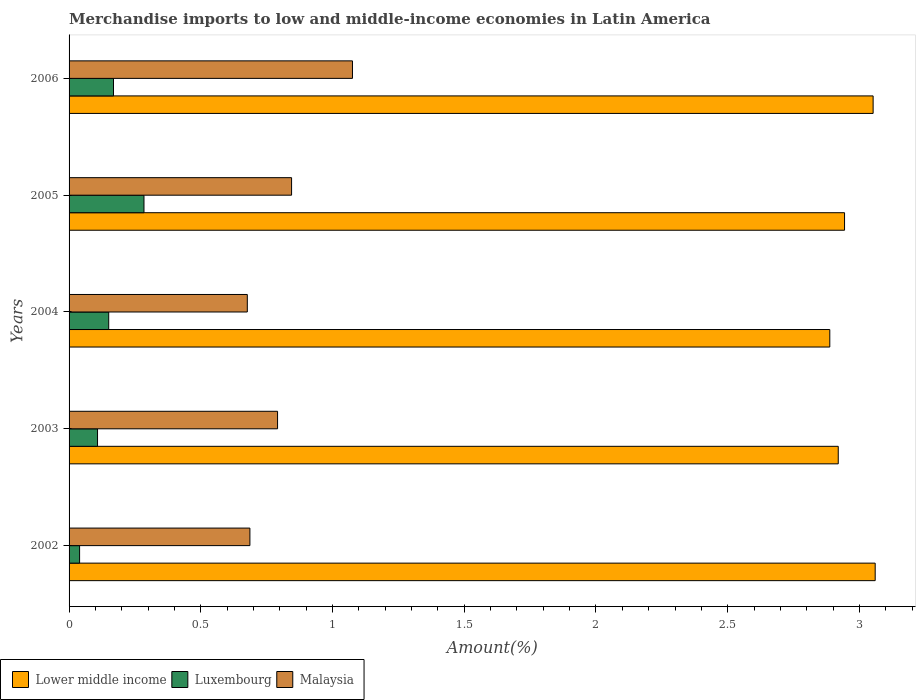Are the number of bars on each tick of the Y-axis equal?
Provide a short and direct response. Yes. What is the percentage of amount earned from merchandise imports in Lower middle income in 2006?
Provide a succinct answer. 3.05. Across all years, what is the maximum percentage of amount earned from merchandise imports in Lower middle income?
Provide a short and direct response. 3.06. Across all years, what is the minimum percentage of amount earned from merchandise imports in Luxembourg?
Your answer should be compact. 0.04. What is the total percentage of amount earned from merchandise imports in Lower middle income in the graph?
Make the answer very short. 14.86. What is the difference between the percentage of amount earned from merchandise imports in Lower middle income in 2002 and that in 2005?
Your response must be concise. 0.12. What is the difference between the percentage of amount earned from merchandise imports in Luxembourg in 2004 and the percentage of amount earned from merchandise imports in Lower middle income in 2006?
Your response must be concise. -2.9. What is the average percentage of amount earned from merchandise imports in Luxembourg per year?
Provide a short and direct response. 0.15. In the year 2006, what is the difference between the percentage of amount earned from merchandise imports in Lower middle income and percentage of amount earned from merchandise imports in Malaysia?
Provide a succinct answer. 1.98. In how many years, is the percentage of amount earned from merchandise imports in Malaysia greater than 0.7 %?
Ensure brevity in your answer.  3. What is the ratio of the percentage of amount earned from merchandise imports in Malaysia in 2004 to that in 2005?
Your answer should be very brief. 0.8. What is the difference between the highest and the second highest percentage of amount earned from merchandise imports in Malaysia?
Your answer should be very brief. 0.23. What is the difference between the highest and the lowest percentage of amount earned from merchandise imports in Lower middle income?
Keep it short and to the point. 0.17. In how many years, is the percentage of amount earned from merchandise imports in Malaysia greater than the average percentage of amount earned from merchandise imports in Malaysia taken over all years?
Provide a short and direct response. 2. Is the sum of the percentage of amount earned from merchandise imports in Malaysia in 2003 and 2005 greater than the maximum percentage of amount earned from merchandise imports in Luxembourg across all years?
Provide a short and direct response. Yes. What does the 3rd bar from the top in 2004 represents?
Your response must be concise. Lower middle income. What does the 2nd bar from the bottom in 2003 represents?
Give a very brief answer. Luxembourg. How many bars are there?
Offer a terse response. 15. What is the difference between two consecutive major ticks on the X-axis?
Your answer should be compact. 0.5. How many legend labels are there?
Give a very brief answer. 3. What is the title of the graph?
Your response must be concise. Merchandise imports to low and middle-income economies in Latin America. What is the label or title of the X-axis?
Make the answer very short. Amount(%). What is the label or title of the Y-axis?
Offer a terse response. Years. What is the Amount(%) in Lower middle income in 2002?
Provide a succinct answer. 3.06. What is the Amount(%) in Luxembourg in 2002?
Ensure brevity in your answer.  0.04. What is the Amount(%) of Malaysia in 2002?
Offer a terse response. 0.69. What is the Amount(%) of Lower middle income in 2003?
Your answer should be very brief. 2.92. What is the Amount(%) in Luxembourg in 2003?
Make the answer very short. 0.11. What is the Amount(%) in Malaysia in 2003?
Your response must be concise. 0.79. What is the Amount(%) of Lower middle income in 2004?
Provide a succinct answer. 2.89. What is the Amount(%) in Luxembourg in 2004?
Offer a very short reply. 0.15. What is the Amount(%) in Malaysia in 2004?
Ensure brevity in your answer.  0.68. What is the Amount(%) of Lower middle income in 2005?
Provide a short and direct response. 2.94. What is the Amount(%) of Luxembourg in 2005?
Offer a terse response. 0.28. What is the Amount(%) in Malaysia in 2005?
Make the answer very short. 0.84. What is the Amount(%) of Lower middle income in 2006?
Make the answer very short. 3.05. What is the Amount(%) of Luxembourg in 2006?
Ensure brevity in your answer.  0.17. What is the Amount(%) of Malaysia in 2006?
Your response must be concise. 1.08. Across all years, what is the maximum Amount(%) of Lower middle income?
Your answer should be very brief. 3.06. Across all years, what is the maximum Amount(%) in Luxembourg?
Ensure brevity in your answer.  0.28. Across all years, what is the maximum Amount(%) in Malaysia?
Give a very brief answer. 1.08. Across all years, what is the minimum Amount(%) in Lower middle income?
Ensure brevity in your answer.  2.89. Across all years, what is the minimum Amount(%) in Luxembourg?
Provide a short and direct response. 0.04. Across all years, what is the minimum Amount(%) of Malaysia?
Make the answer very short. 0.68. What is the total Amount(%) in Lower middle income in the graph?
Provide a short and direct response. 14.86. What is the total Amount(%) in Luxembourg in the graph?
Ensure brevity in your answer.  0.75. What is the total Amount(%) in Malaysia in the graph?
Offer a terse response. 4.07. What is the difference between the Amount(%) of Lower middle income in 2002 and that in 2003?
Provide a short and direct response. 0.14. What is the difference between the Amount(%) in Luxembourg in 2002 and that in 2003?
Offer a terse response. -0.07. What is the difference between the Amount(%) in Malaysia in 2002 and that in 2003?
Keep it short and to the point. -0.1. What is the difference between the Amount(%) in Lower middle income in 2002 and that in 2004?
Ensure brevity in your answer.  0.17. What is the difference between the Amount(%) of Luxembourg in 2002 and that in 2004?
Ensure brevity in your answer.  -0.11. What is the difference between the Amount(%) in Malaysia in 2002 and that in 2004?
Your response must be concise. 0.01. What is the difference between the Amount(%) in Lower middle income in 2002 and that in 2005?
Keep it short and to the point. 0.12. What is the difference between the Amount(%) of Luxembourg in 2002 and that in 2005?
Give a very brief answer. -0.24. What is the difference between the Amount(%) in Malaysia in 2002 and that in 2005?
Provide a succinct answer. -0.16. What is the difference between the Amount(%) in Lower middle income in 2002 and that in 2006?
Make the answer very short. 0.01. What is the difference between the Amount(%) in Luxembourg in 2002 and that in 2006?
Your answer should be very brief. -0.13. What is the difference between the Amount(%) of Malaysia in 2002 and that in 2006?
Your answer should be very brief. -0.39. What is the difference between the Amount(%) in Lower middle income in 2003 and that in 2004?
Provide a succinct answer. 0.03. What is the difference between the Amount(%) of Luxembourg in 2003 and that in 2004?
Ensure brevity in your answer.  -0.04. What is the difference between the Amount(%) in Malaysia in 2003 and that in 2004?
Give a very brief answer. 0.11. What is the difference between the Amount(%) in Lower middle income in 2003 and that in 2005?
Provide a short and direct response. -0.02. What is the difference between the Amount(%) in Luxembourg in 2003 and that in 2005?
Your response must be concise. -0.18. What is the difference between the Amount(%) of Malaysia in 2003 and that in 2005?
Make the answer very short. -0.05. What is the difference between the Amount(%) of Lower middle income in 2003 and that in 2006?
Your answer should be very brief. -0.13. What is the difference between the Amount(%) of Luxembourg in 2003 and that in 2006?
Keep it short and to the point. -0.06. What is the difference between the Amount(%) in Malaysia in 2003 and that in 2006?
Provide a short and direct response. -0.28. What is the difference between the Amount(%) of Lower middle income in 2004 and that in 2005?
Provide a short and direct response. -0.06. What is the difference between the Amount(%) in Luxembourg in 2004 and that in 2005?
Ensure brevity in your answer.  -0.13. What is the difference between the Amount(%) in Malaysia in 2004 and that in 2005?
Offer a very short reply. -0.17. What is the difference between the Amount(%) of Lower middle income in 2004 and that in 2006?
Your answer should be very brief. -0.16. What is the difference between the Amount(%) of Luxembourg in 2004 and that in 2006?
Provide a succinct answer. -0.02. What is the difference between the Amount(%) in Malaysia in 2004 and that in 2006?
Your response must be concise. -0.4. What is the difference between the Amount(%) in Lower middle income in 2005 and that in 2006?
Your response must be concise. -0.11. What is the difference between the Amount(%) of Luxembourg in 2005 and that in 2006?
Your answer should be compact. 0.12. What is the difference between the Amount(%) in Malaysia in 2005 and that in 2006?
Offer a very short reply. -0.23. What is the difference between the Amount(%) of Lower middle income in 2002 and the Amount(%) of Luxembourg in 2003?
Your answer should be very brief. 2.95. What is the difference between the Amount(%) of Lower middle income in 2002 and the Amount(%) of Malaysia in 2003?
Ensure brevity in your answer.  2.27. What is the difference between the Amount(%) of Luxembourg in 2002 and the Amount(%) of Malaysia in 2003?
Provide a succinct answer. -0.75. What is the difference between the Amount(%) in Lower middle income in 2002 and the Amount(%) in Luxembourg in 2004?
Provide a succinct answer. 2.91. What is the difference between the Amount(%) in Lower middle income in 2002 and the Amount(%) in Malaysia in 2004?
Provide a short and direct response. 2.38. What is the difference between the Amount(%) of Luxembourg in 2002 and the Amount(%) of Malaysia in 2004?
Make the answer very short. -0.64. What is the difference between the Amount(%) of Lower middle income in 2002 and the Amount(%) of Luxembourg in 2005?
Keep it short and to the point. 2.78. What is the difference between the Amount(%) in Lower middle income in 2002 and the Amount(%) in Malaysia in 2005?
Keep it short and to the point. 2.22. What is the difference between the Amount(%) in Luxembourg in 2002 and the Amount(%) in Malaysia in 2005?
Give a very brief answer. -0.8. What is the difference between the Amount(%) of Lower middle income in 2002 and the Amount(%) of Luxembourg in 2006?
Provide a short and direct response. 2.89. What is the difference between the Amount(%) of Lower middle income in 2002 and the Amount(%) of Malaysia in 2006?
Ensure brevity in your answer.  1.98. What is the difference between the Amount(%) in Luxembourg in 2002 and the Amount(%) in Malaysia in 2006?
Give a very brief answer. -1.04. What is the difference between the Amount(%) of Lower middle income in 2003 and the Amount(%) of Luxembourg in 2004?
Your answer should be compact. 2.77. What is the difference between the Amount(%) of Lower middle income in 2003 and the Amount(%) of Malaysia in 2004?
Offer a very short reply. 2.24. What is the difference between the Amount(%) in Luxembourg in 2003 and the Amount(%) in Malaysia in 2004?
Make the answer very short. -0.57. What is the difference between the Amount(%) in Lower middle income in 2003 and the Amount(%) in Luxembourg in 2005?
Keep it short and to the point. 2.64. What is the difference between the Amount(%) in Lower middle income in 2003 and the Amount(%) in Malaysia in 2005?
Your response must be concise. 2.08. What is the difference between the Amount(%) of Luxembourg in 2003 and the Amount(%) of Malaysia in 2005?
Provide a short and direct response. -0.74. What is the difference between the Amount(%) in Lower middle income in 2003 and the Amount(%) in Luxembourg in 2006?
Ensure brevity in your answer.  2.75. What is the difference between the Amount(%) in Lower middle income in 2003 and the Amount(%) in Malaysia in 2006?
Your answer should be compact. 1.84. What is the difference between the Amount(%) of Luxembourg in 2003 and the Amount(%) of Malaysia in 2006?
Offer a terse response. -0.97. What is the difference between the Amount(%) of Lower middle income in 2004 and the Amount(%) of Luxembourg in 2005?
Keep it short and to the point. 2.6. What is the difference between the Amount(%) of Lower middle income in 2004 and the Amount(%) of Malaysia in 2005?
Your answer should be compact. 2.04. What is the difference between the Amount(%) in Luxembourg in 2004 and the Amount(%) in Malaysia in 2005?
Offer a terse response. -0.69. What is the difference between the Amount(%) in Lower middle income in 2004 and the Amount(%) in Luxembourg in 2006?
Your response must be concise. 2.72. What is the difference between the Amount(%) of Lower middle income in 2004 and the Amount(%) of Malaysia in 2006?
Your response must be concise. 1.81. What is the difference between the Amount(%) of Luxembourg in 2004 and the Amount(%) of Malaysia in 2006?
Ensure brevity in your answer.  -0.93. What is the difference between the Amount(%) in Lower middle income in 2005 and the Amount(%) in Luxembourg in 2006?
Keep it short and to the point. 2.77. What is the difference between the Amount(%) in Lower middle income in 2005 and the Amount(%) in Malaysia in 2006?
Make the answer very short. 1.87. What is the difference between the Amount(%) in Luxembourg in 2005 and the Amount(%) in Malaysia in 2006?
Your answer should be compact. -0.79. What is the average Amount(%) in Lower middle income per year?
Provide a short and direct response. 2.97. What is the average Amount(%) of Luxembourg per year?
Provide a short and direct response. 0.15. What is the average Amount(%) of Malaysia per year?
Keep it short and to the point. 0.81. In the year 2002, what is the difference between the Amount(%) of Lower middle income and Amount(%) of Luxembourg?
Make the answer very short. 3.02. In the year 2002, what is the difference between the Amount(%) in Lower middle income and Amount(%) in Malaysia?
Ensure brevity in your answer.  2.37. In the year 2002, what is the difference between the Amount(%) of Luxembourg and Amount(%) of Malaysia?
Make the answer very short. -0.65. In the year 2003, what is the difference between the Amount(%) in Lower middle income and Amount(%) in Luxembourg?
Your answer should be very brief. 2.81. In the year 2003, what is the difference between the Amount(%) of Lower middle income and Amount(%) of Malaysia?
Offer a very short reply. 2.13. In the year 2003, what is the difference between the Amount(%) of Luxembourg and Amount(%) of Malaysia?
Provide a succinct answer. -0.68. In the year 2004, what is the difference between the Amount(%) in Lower middle income and Amount(%) in Luxembourg?
Your answer should be very brief. 2.74. In the year 2004, what is the difference between the Amount(%) of Lower middle income and Amount(%) of Malaysia?
Your response must be concise. 2.21. In the year 2004, what is the difference between the Amount(%) of Luxembourg and Amount(%) of Malaysia?
Provide a succinct answer. -0.53. In the year 2005, what is the difference between the Amount(%) of Lower middle income and Amount(%) of Luxembourg?
Provide a succinct answer. 2.66. In the year 2005, what is the difference between the Amount(%) of Lower middle income and Amount(%) of Malaysia?
Offer a terse response. 2.1. In the year 2005, what is the difference between the Amount(%) of Luxembourg and Amount(%) of Malaysia?
Offer a very short reply. -0.56. In the year 2006, what is the difference between the Amount(%) in Lower middle income and Amount(%) in Luxembourg?
Give a very brief answer. 2.88. In the year 2006, what is the difference between the Amount(%) in Lower middle income and Amount(%) in Malaysia?
Give a very brief answer. 1.98. In the year 2006, what is the difference between the Amount(%) in Luxembourg and Amount(%) in Malaysia?
Offer a terse response. -0.91. What is the ratio of the Amount(%) in Lower middle income in 2002 to that in 2003?
Your answer should be compact. 1.05. What is the ratio of the Amount(%) in Luxembourg in 2002 to that in 2003?
Ensure brevity in your answer.  0.37. What is the ratio of the Amount(%) of Malaysia in 2002 to that in 2003?
Offer a very short reply. 0.87. What is the ratio of the Amount(%) of Lower middle income in 2002 to that in 2004?
Keep it short and to the point. 1.06. What is the ratio of the Amount(%) of Luxembourg in 2002 to that in 2004?
Provide a short and direct response. 0.27. What is the ratio of the Amount(%) in Malaysia in 2002 to that in 2004?
Give a very brief answer. 1.01. What is the ratio of the Amount(%) of Lower middle income in 2002 to that in 2005?
Ensure brevity in your answer.  1.04. What is the ratio of the Amount(%) of Luxembourg in 2002 to that in 2005?
Your answer should be compact. 0.14. What is the ratio of the Amount(%) of Malaysia in 2002 to that in 2005?
Offer a terse response. 0.81. What is the ratio of the Amount(%) of Luxembourg in 2002 to that in 2006?
Provide a short and direct response. 0.24. What is the ratio of the Amount(%) of Malaysia in 2002 to that in 2006?
Give a very brief answer. 0.64. What is the ratio of the Amount(%) of Lower middle income in 2003 to that in 2004?
Offer a terse response. 1.01. What is the ratio of the Amount(%) of Luxembourg in 2003 to that in 2004?
Your answer should be compact. 0.72. What is the ratio of the Amount(%) in Malaysia in 2003 to that in 2004?
Make the answer very short. 1.17. What is the ratio of the Amount(%) of Luxembourg in 2003 to that in 2005?
Give a very brief answer. 0.38. What is the ratio of the Amount(%) in Malaysia in 2003 to that in 2005?
Keep it short and to the point. 0.94. What is the ratio of the Amount(%) of Lower middle income in 2003 to that in 2006?
Give a very brief answer. 0.96. What is the ratio of the Amount(%) of Luxembourg in 2003 to that in 2006?
Make the answer very short. 0.64. What is the ratio of the Amount(%) of Malaysia in 2003 to that in 2006?
Your answer should be compact. 0.74. What is the ratio of the Amount(%) of Lower middle income in 2004 to that in 2005?
Ensure brevity in your answer.  0.98. What is the ratio of the Amount(%) of Luxembourg in 2004 to that in 2005?
Your answer should be very brief. 0.53. What is the ratio of the Amount(%) of Malaysia in 2004 to that in 2005?
Provide a succinct answer. 0.8. What is the ratio of the Amount(%) of Lower middle income in 2004 to that in 2006?
Give a very brief answer. 0.95. What is the ratio of the Amount(%) of Luxembourg in 2004 to that in 2006?
Your response must be concise. 0.89. What is the ratio of the Amount(%) of Malaysia in 2004 to that in 2006?
Provide a short and direct response. 0.63. What is the ratio of the Amount(%) in Lower middle income in 2005 to that in 2006?
Offer a terse response. 0.96. What is the ratio of the Amount(%) in Luxembourg in 2005 to that in 2006?
Offer a terse response. 1.69. What is the ratio of the Amount(%) in Malaysia in 2005 to that in 2006?
Your answer should be very brief. 0.79. What is the difference between the highest and the second highest Amount(%) of Lower middle income?
Provide a succinct answer. 0.01. What is the difference between the highest and the second highest Amount(%) of Luxembourg?
Your answer should be very brief. 0.12. What is the difference between the highest and the second highest Amount(%) of Malaysia?
Your answer should be very brief. 0.23. What is the difference between the highest and the lowest Amount(%) in Lower middle income?
Offer a very short reply. 0.17. What is the difference between the highest and the lowest Amount(%) in Luxembourg?
Your response must be concise. 0.24. What is the difference between the highest and the lowest Amount(%) of Malaysia?
Keep it short and to the point. 0.4. 